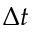<formula> <loc_0><loc_0><loc_500><loc_500>\Delta t</formula> 